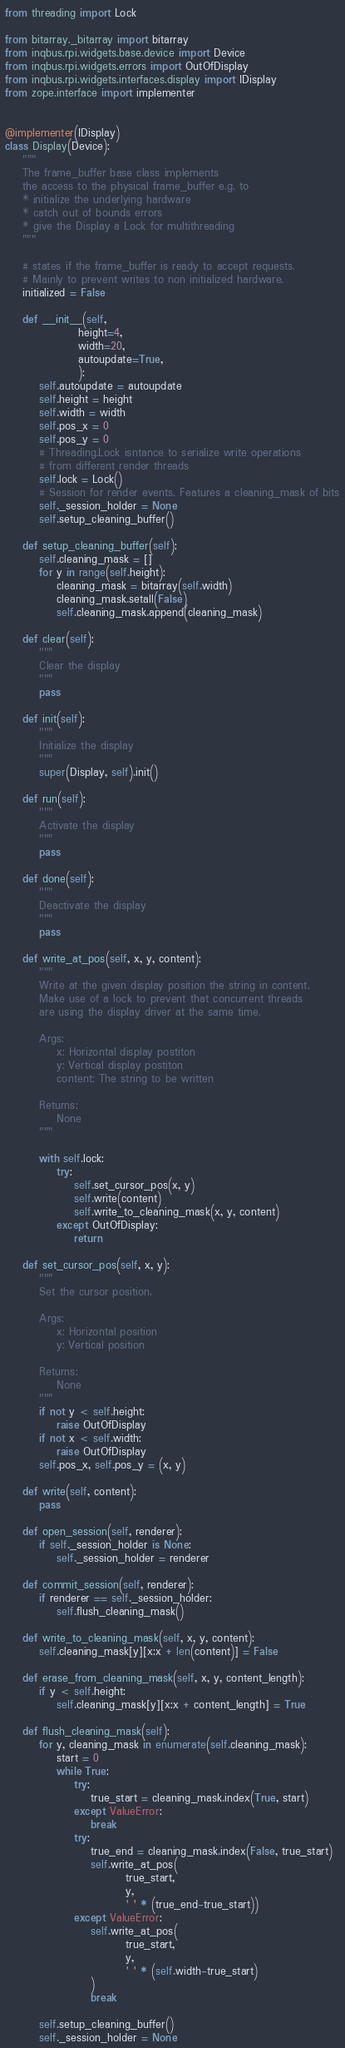<code> <loc_0><loc_0><loc_500><loc_500><_Python_>from threading import Lock

from bitarray._bitarray import bitarray
from inqbus.rpi.widgets.base.device import Device
from inqbus.rpi.widgets.errors import OutOfDisplay
from inqbus.rpi.widgets.interfaces.display import IDisplay
from zope.interface import implementer


@implementer(IDisplay)
class Display(Device):
    """
    The frame_buffer base class implements
    the access to the physical frame_buffer e.g. to
    * initialize the underlying hardware
    * catch out of bounds errors
    * give the Display a Lock for multithreading
    """

    # states if the frame_buffer is ready to accept requests.
    # Mainly to prevent writes to non initialized hardware.
    initialized = False

    def __init__(self,
                 height=4,
                 width=20,
                 autoupdate=True,
                 ):
        self.autoupdate = autoupdate
        self.height = height
        self.width = width
        self.pos_x = 0
        self.pos_y = 0
        # Threading.Lock isntance to serialize write operations
        # from different render threads
        self.lock = Lock()
        # Session for render events. Features a cleaning_mask of bits
        self._session_holder = None
        self.setup_cleaning_buffer()

    def setup_cleaning_buffer(self):
        self.cleaning_mask = []
        for y in range(self.height):
            cleaning_mask = bitarray(self.width)
            cleaning_mask.setall(False)
            self.cleaning_mask.append(cleaning_mask)

    def clear(self):
        """
        Clear the display
        """
        pass

    def init(self):
        """
        Initialize the display
        """
        super(Display, self).init()

    def run(self):
        """
        Activate the display
        """
        pass

    def done(self):
        """
        Deactivate the display
        """
        pass

    def write_at_pos(self, x, y, content):
        """
        Write at the given display position the string in content.
        Make use of a lock to prevent that concurrent threads
        are using the display driver at the same time.

        Args:
            x: Horizontal display postiton
            y: Vertical display postiton
            content: The string to be written

        Returns:
            None
        """

        with self.lock:
            try:
                self.set_cursor_pos(x, y)
                self.write(content)
                self.write_to_cleaning_mask(x, y, content)
            except OutOfDisplay:
                return

    def set_cursor_pos(self, x, y):
        """
        Set the cursor position.

        Args:
            x: Horizontal position
            y: Vertical position

        Returns:
            None
        """
        if not y < self.height:
            raise OutOfDisplay
        if not x < self.width:
            raise OutOfDisplay
        self.pos_x, self.pos_y = (x, y)

    def write(self, content):
        pass

    def open_session(self, renderer):
        if self._session_holder is None:
            self._session_holder = renderer

    def commit_session(self, renderer):
        if renderer == self._session_holder:
            self.flush_cleaning_mask()

    def write_to_cleaning_mask(self, x, y, content):
        self.cleaning_mask[y][x:x + len(content)] = False

    def erase_from_cleaning_mask(self, x, y, content_length):
        if y < self.height:
            self.cleaning_mask[y][x:x + content_length] = True

    def flush_cleaning_mask(self):
        for y, cleaning_mask in enumerate(self.cleaning_mask):
            start = 0
            while True:
                try:
                    true_start = cleaning_mask.index(True, start)
                except ValueError:
                    break
                try:
                    true_end = cleaning_mask.index(False, true_start)
                    self.write_at_pos(
                            true_start,
                            y,
                            ' ' * (true_end-true_start))
                except ValueError:
                    self.write_at_pos(
                            true_start,
                            y,
                            ' ' * (self.width-true_start)
                    )
                    break

        self.setup_cleaning_buffer()
        self._session_holder = None
</code> 